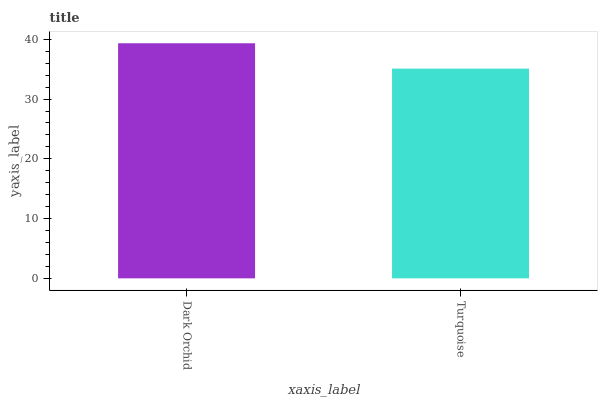Is Turquoise the minimum?
Answer yes or no. Yes. Is Dark Orchid the maximum?
Answer yes or no. Yes. Is Turquoise the maximum?
Answer yes or no. No. Is Dark Orchid greater than Turquoise?
Answer yes or no. Yes. Is Turquoise less than Dark Orchid?
Answer yes or no. Yes. Is Turquoise greater than Dark Orchid?
Answer yes or no. No. Is Dark Orchid less than Turquoise?
Answer yes or no. No. Is Dark Orchid the high median?
Answer yes or no. Yes. Is Turquoise the low median?
Answer yes or no. Yes. Is Turquoise the high median?
Answer yes or no. No. Is Dark Orchid the low median?
Answer yes or no. No. 